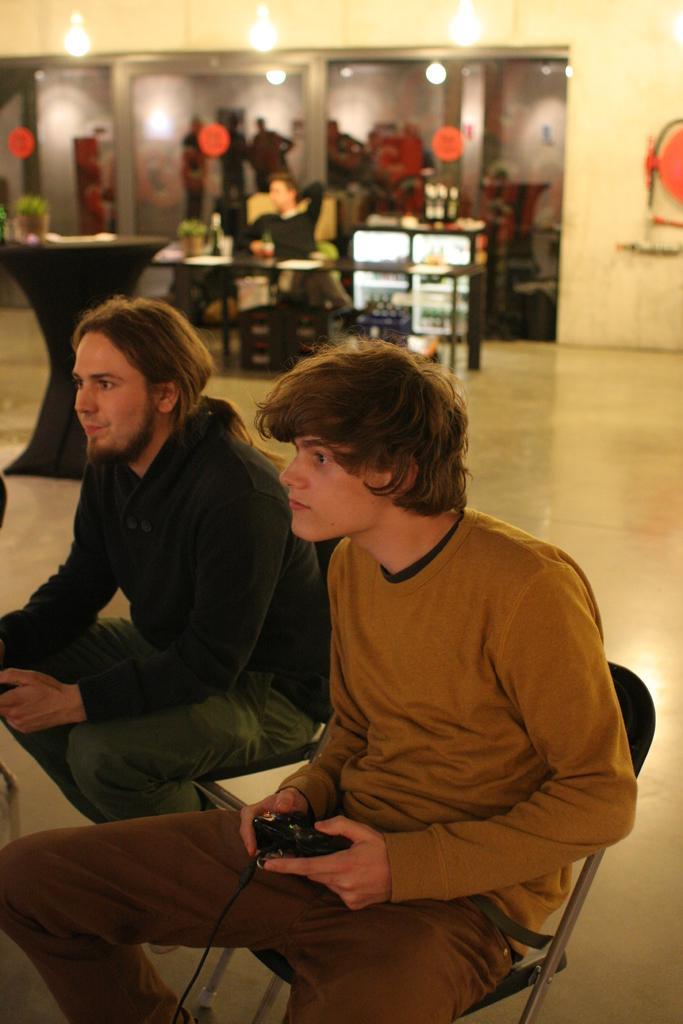Can you describe this image briefly? In this image we can see people sitting. The man sitting in the center is holding a remote. On the left there is a table. In the background there is a wall and we can see doors. At the top there are lights. There is an object. 